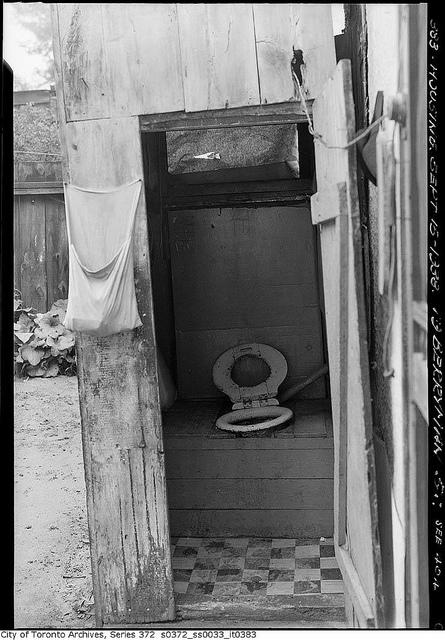Is the seat level?
Quick response, please. No. Would you use this bathroom?
Answer briefly. No. Is this an outside restroom?
Be succinct. Yes. Why is the door open?
Answer briefly. Unknown. Is this a fancy restroom?
Be succinct. No. 